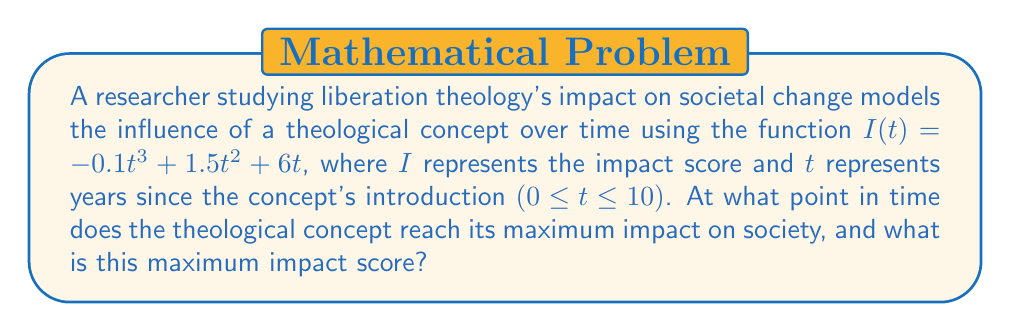Could you help me with this problem? To find the maximum impact, we need to determine the critical points of the function and evaluate them:

1) First, find the derivative of $I(t)$:
   $$I'(t) = -0.3t^2 + 3t + 6$$

2) Set $I'(t) = 0$ to find critical points:
   $$-0.3t^2 + 3t + 6 = 0$$

3) Solve the quadratic equation:
   $$t = \frac{-3 \pm \sqrt{3^2 - 4(-0.3)(6)}}{2(-0.3)}$$
   $$t = \frac{-3 \pm \sqrt{9 + 7.2}}{-0.6}$$
   $$t = \frac{-3 \pm \sqrt{16.2}}{-0.6}$$
   $$t = \frac{-3 \pm 4.025}{-0.6}$$

   This gives us two solutions:
   $t_1 \approx 11.71$ (outside our domain)
   $t_2 \approx 1.71$

4) Check the endpoints of the domain [0, 10]:
   $I(0) = 0$
   $I(10) = -100 + 150 + 60 = 110$

5) Evaluate $I(t)$ at $t_2 = 1.71$:
   $I(1.71) \approx -0.1(1.71)^3 + 1.5(1.71)^2 + 6(1.71) \approx 13.65$

6) Compare the values:
   $I(0) = 0$
   $I(1.71) \approx 13.65$
   $I(10) = 110$

The maximum impact occurs at $t = 10$ years with an impact score of 110.
Answer: 10 years; 110 